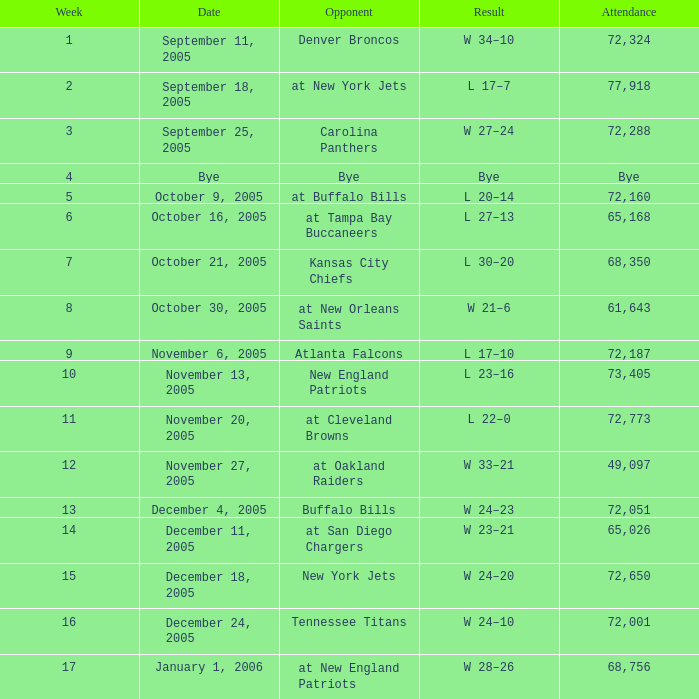In what Week was the Attendance 49,097? 12.0. 